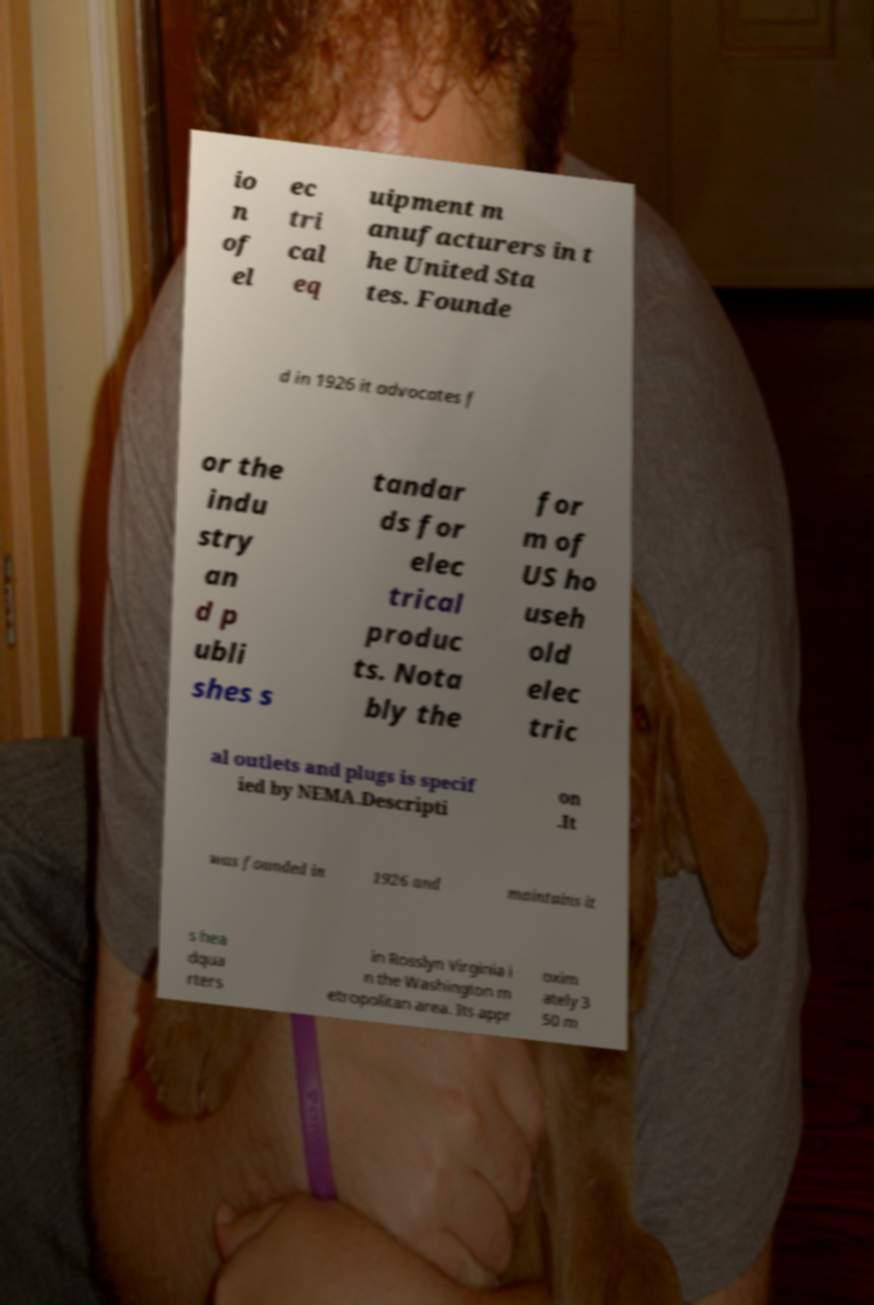For documentation purposes, I need the text within this image transcribed. Could you provide that? io n of el ec tri cal eq uipment m anufacturers in t he United Sta tes. Founde d in 1926 it advocates f or the indu stry an d p ubli shes s tandar ds for elec trical produc ts. Nota bly the for m of US ho useh old elec tric al outlets and plugs is specif ied by NEMA.Descripti on .It was founded in 1926 and maintains it s hea dqua rters in Rosslyn Virginia i n the Washington m etropolitan area. Its appr oxim ately 3 50 m 